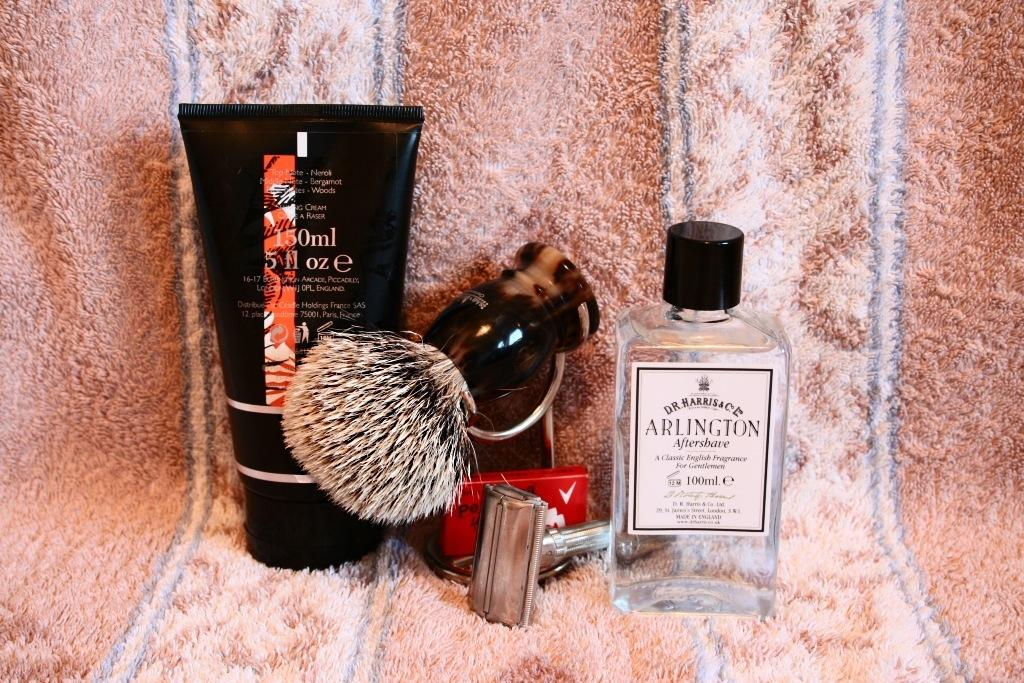<image>
Write a terse but informative summary of the picture. Men's shaving supplies with a bottle of Arlington aftershave. 